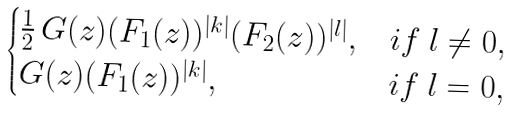Convert formula to latex. <formula><loc_0><loc_0><loc_500><loc_500>\begin{cases} \frac { 1 } { 2 } \, G ( z ) ( F _ { 1 } ( z ) ) ^ { | k | } ( F _ { 2 } ( z ) ) ^ { | l | } , & i f \ l \neq 0 , \\ G ( z ) ( F _ { 1 } ( z ) ) ^ { | k | } , & i f \ l = 0 , \end{cases}</formula> 